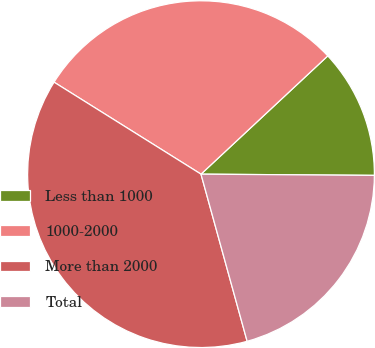Convert chart to OTSL. <chart><loc_0><loc_0><loc_500><loc_500><pie_chart><fcel>Less than 1000<fcel>1000-2000<fcel>More than 2000<fcel>Total<nl><fcel>12.06%<fcel>29.15%<fcel>38.19%<fcel>20.6%<nl></chart> 